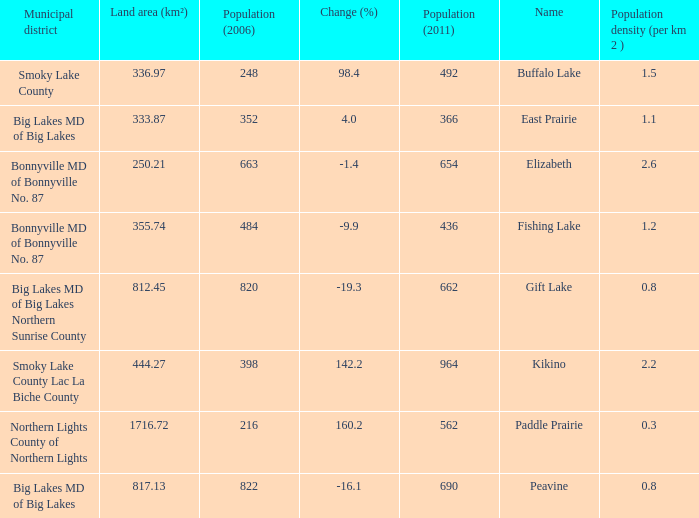What is the density per km in Smoky Lake County? 1.5. 